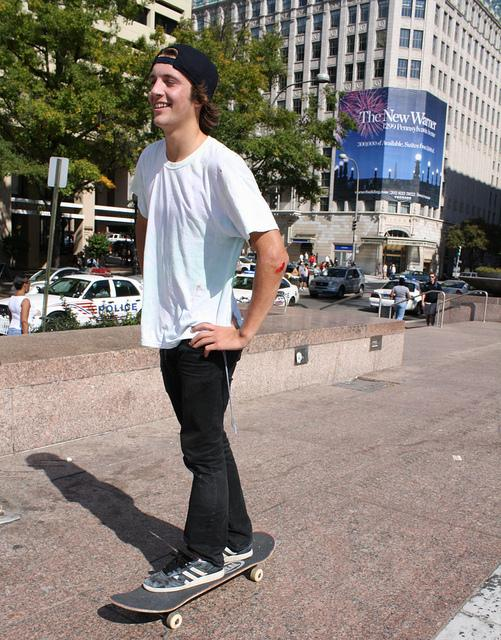What type of shoes is the boy wearing? Please explain your reasoning. adidas. He is wearing adidas. 